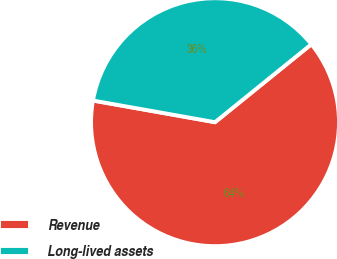Convert chart to OTSL. <chart><loc_0><loc_0><loc_500><loc_500><pie_chart><fcel>Revenue<fcel>Long-lived assets<nl><fcel>63.62%<fcel>36.38%<nl></chart> 